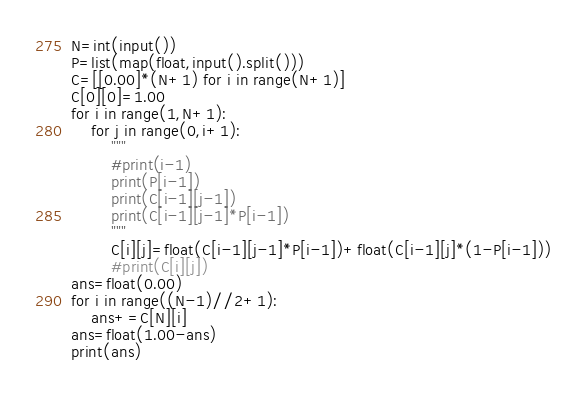<code> <loc_0><loc_0><loc_500><loc_500><_Python_>N=int(input())
P=list(map(float,input().split()))
C=[[0.00]*(N+1) for i in range(N+1)]
C[0][0]=1.00
for i in range(1,N+1):
    for j in range(0,i+1):
        """
        #print(i-1)
        print(P[i-1])
        print(C[i-1][j-1])
        print(C[i-1][j-1]*P[i-1])
        """
        C[i][j]=float(C[i-1][j-1]*P[i-1])+float(C[i-1][j]*(1-P[i-1]))
        #print(C[i][j])
ans=float(0.00)
for i in range((N-1)//2+1):
    ans+=C[N][i]
ans=float(1.00-ans)
print(ans)
</code> 